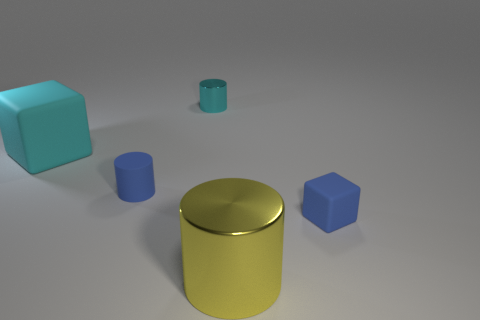Is the number of rubber cylinders on the left side of the cyan matte thing the same as the number of small metal cylinders in front of the small rubber cylinder?
Offer a very short reply. Yes. There is a rubber cube left of the matte cylinder; is it the same size as the metal cylinder in front of the big matte cube?
Your answer should be compact. Yes. There is a cylinder that is both in front of the tiny cyan metal thing and behind the blue cube; what is it made of?
Give a very brief answer. Rubber. Are there fewer cyan cylinders than large yellow cubes?
Give a very brief answer. No. What is the size of the rubber object that is behind the tiny rubber thing that is on the left side of the big yellow object?
Offer a very short reply. Large. There is a small matte thing left of the cylinder that is on the right side of the metallic object that is behind the large yellow shiny object; what is its shape?
Your response must be concise. Cylinder. What is the color of the large object that is the same material as the tiny cube?
Ensure brevity in your answer.  Cyan. There is a big thing to the left of the tiny cylinder behind the cyan matte thing behind the tiny blue matte cylinder; what is its color?
Your answer should be compact. Cyan. How many cylinders are either large blue matte objects or yellow objects?
Provide a succinct answer. 1. There is a thing that is the same color as the tiny rubber cylinder; what material is it?
Keep it short and to the point. Rubber. 